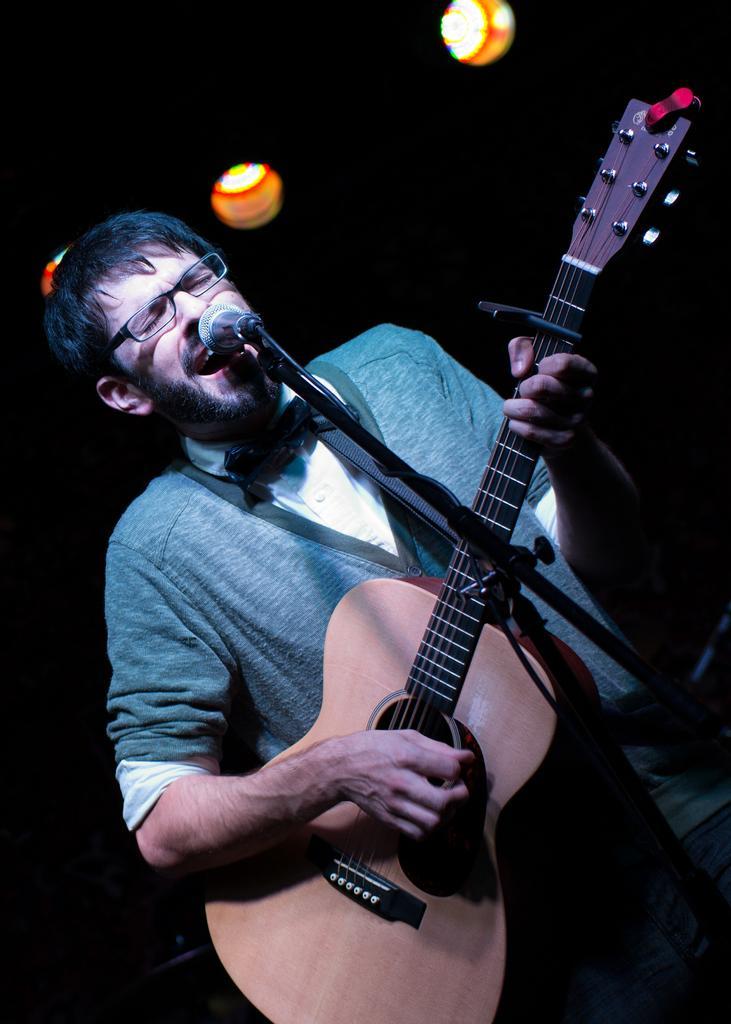Describe this image in one or two sentences. A man wearing specs is holding guitar and playing. In front of him there is mic and mic stand. In the background there are lights. 